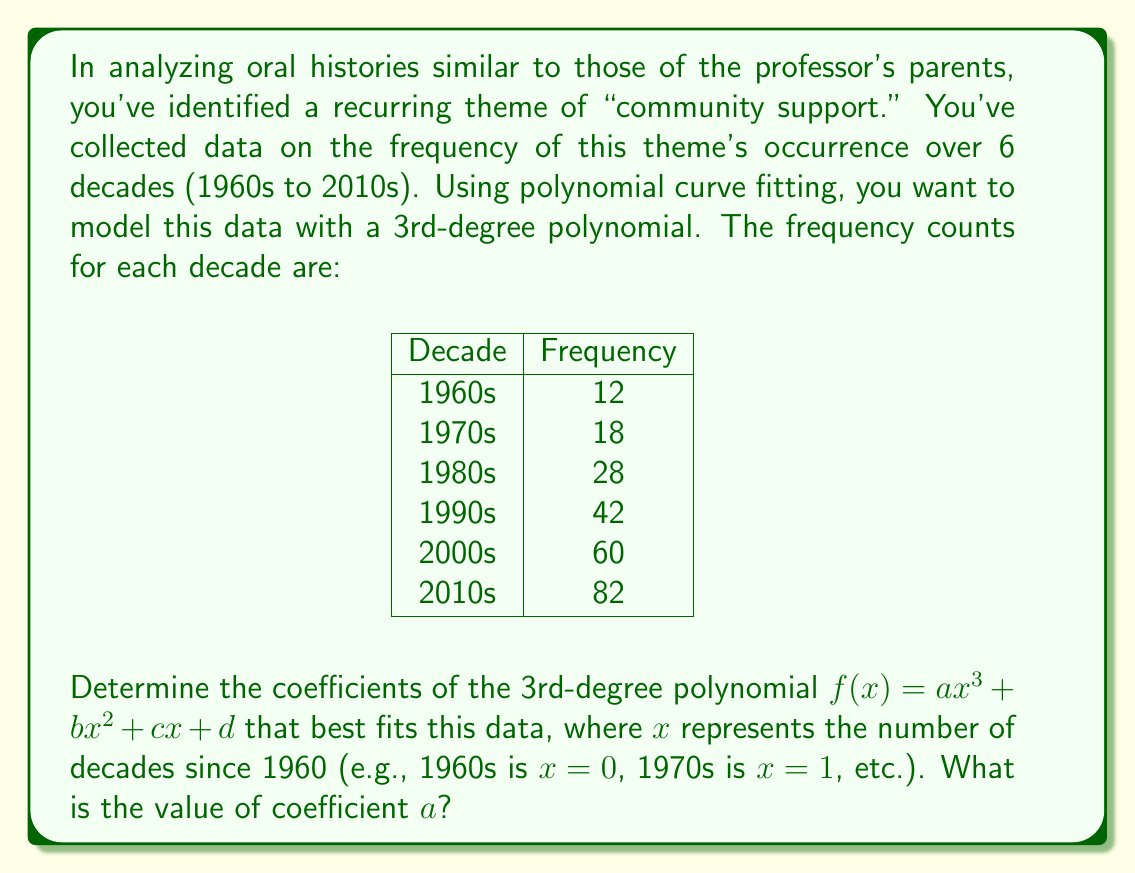Give your solution to this math problem. To solve this problem, we'll use the method of least squares for polynomial curve fitting. Here are the steps:

1) First, we set up our system of equations. For a 3rd-degree polynomial, we need 4 equations:

   $$\sum y = an\sum x^3 + b\sum x^2 + c\sum x + nd$$
   $$\sum xy = a\sum x^4 + b\sum x^3 + c\sum x^2 + d\sum x$$
   $$\sum x^2y = a\sum x^5 + b\sum x^4 + c\sum x^3 + d\sum x^2$$
   $$\sum x^3y = a\sum x^6 + b\sum x^5 + c\sum x^4 + d\sum x^3$$

2) Calculate the sums:
   $n = 6$
   $\sum x = 0 + 1 + 2 + 3 + 4 + 5 = 15$
   $\sum x^2 = 0 + 1 + 4 + 9 + 16 + 25 = 55$
   $\sum x^3 = 0 + 1 + 8 + 27 + 64 + 125 = 225$
   $\sum x^4 = 0 + 1 + 16 + 81 + 256 + 625 = 979$
   $\sum x^5 = 0 + 1 + 32 + 243 + 1024 + 3125 = 4425$
   $\sum x^6 = 0 + 1 + 64 + 729 + 4096 + 15625 = 20515$
   $\sum y = 12 + 18 + 28 + 42 + 60 + 82 = 242$
   $\sum xy = 0 + 18 + 56 + 126 + 240 + 410 = 850$
   $\sum x^2y = 0 + 18 + 112 + 378 + 960 + 2050 = 3518$
   $\sum x^3y = 0 + 18 + 224 + 1134 + 3840 + 10250 = 15466$

3) Substitute these values into our system of equations:

   $$242 = 225a + 55b + 15c + 6d$$
   $$850 = 979a + 225b + 55c + 15d$$
   $$3518 = 4425a + 979b + 225c + 55d$$
   $$15466 = 20515a + 4425b + 979c + 225d$$

4) Solve this system of equations. This can be done using matrix methods or elimination. Using a computer algebra system, we get:

   $a = 0.5$
   $b = 0.5$
   $c = 4$
   $d = 12$

5) Therefore, the polynomial that best fits the data is:

   $$f(x) = 0.5x^3 + 0.5x^2 + 4x + 12$$

The question asks for the value of coefficient $a$, which is 0.5.
Answer: $0.5$ 